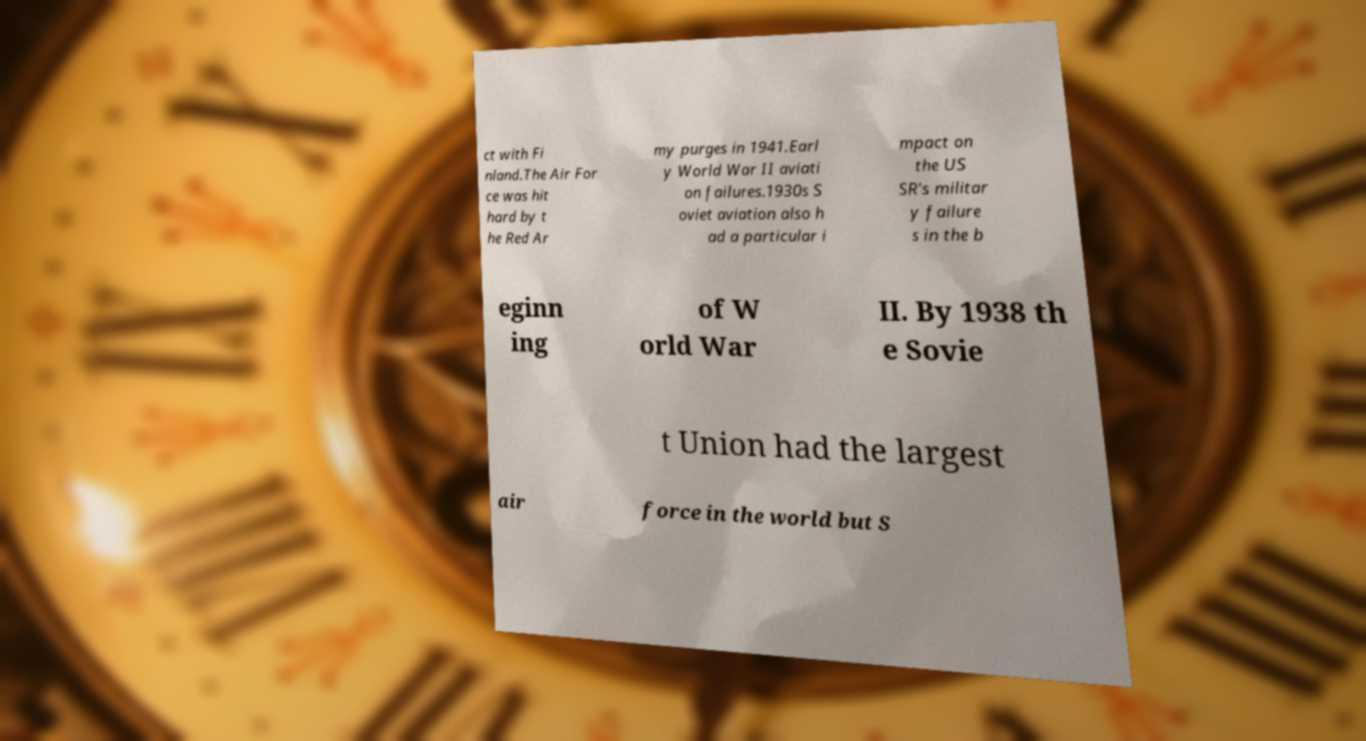Could you assist in decoding the text presented in this image and type it out clearly? ct with Fi nland.The Air For ce was hit hard by t he Red Ar my purges in 1941.Earl y World War II aviati on failures.1930s S oviet aviation also h ad a particular i mpact on the US SR's militar y failure s in the b eginn ing of W orld War II. By 1938 th e Sovie t Union had the largest air force in the world but S 